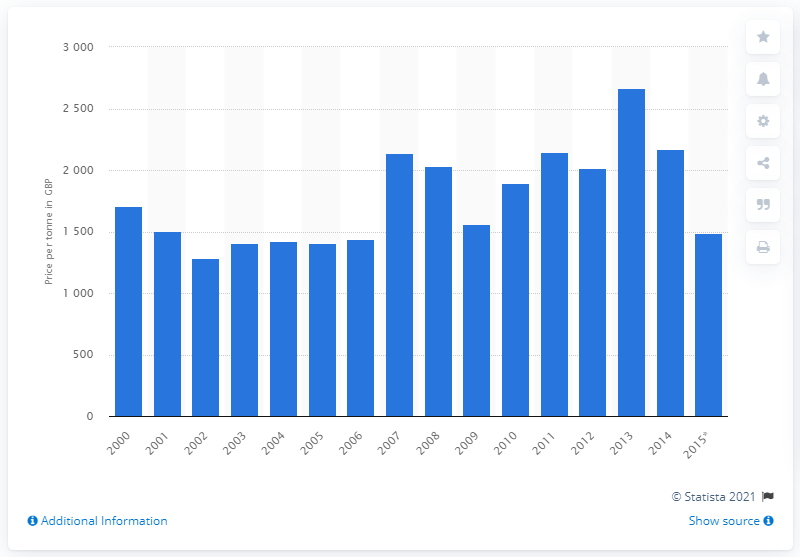Mention a couple of crucial points in this snapshot. In 2012 and 2016, the average price per tonne of skimmed milk powder was approximately 2016.67. 